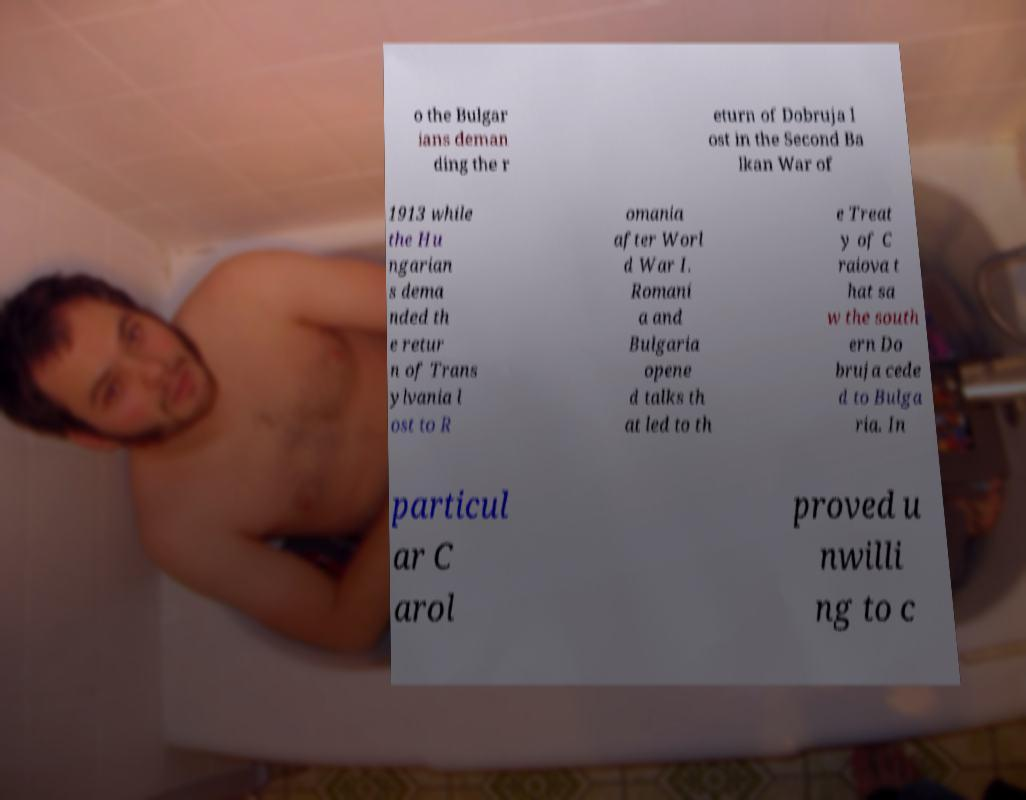Can you accurately transcribe the text from the provided image for me? o the Bulgar ians deman ding the r eturn of Dobruja l ost in the Second Ba lkan War of 1913 while the Hu ngarian s dema nded th e retur n of Trans ylvania l ost to R omania after Worl d War I. Romani a and Bulgaria opene d talks th at led to th e Treat y of C raiova t hat sa w the south ern Do bruja cede d to Bulga ria. In particul ar C arol proved u nwilli ng to c 